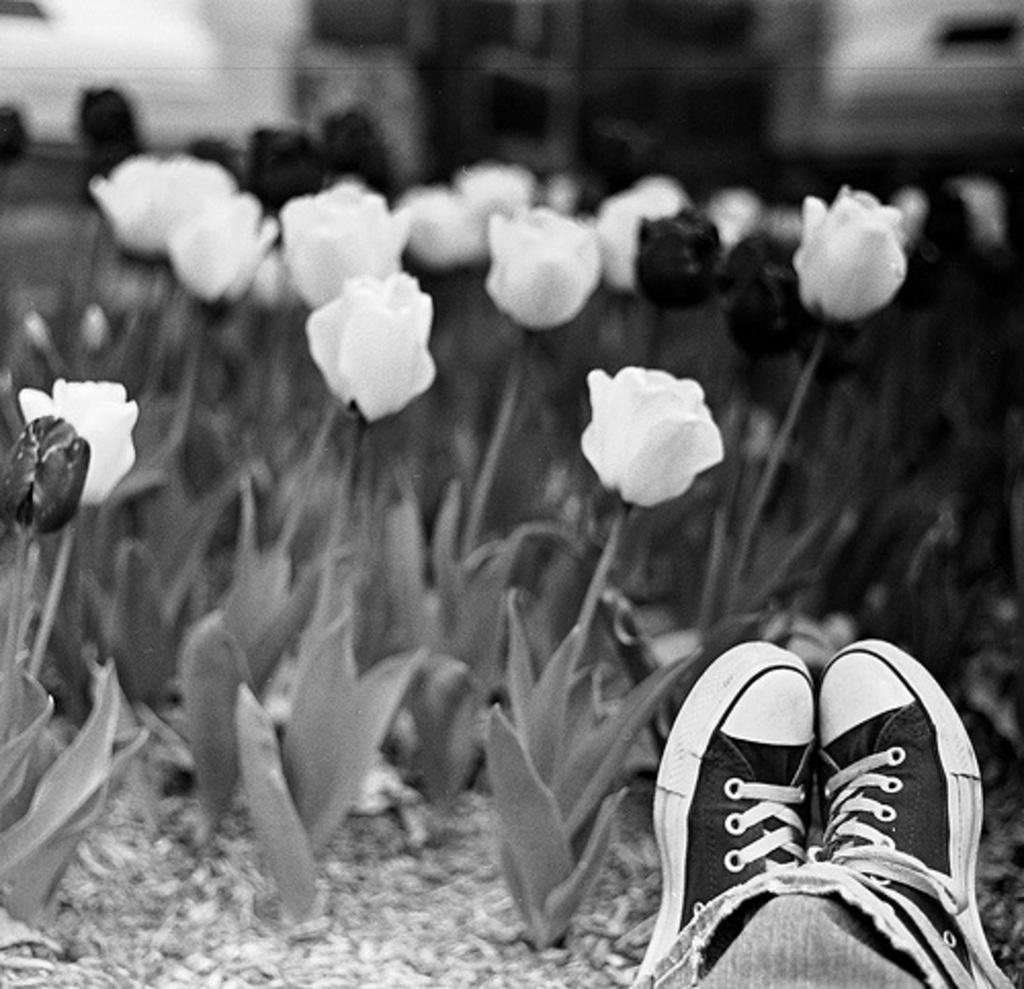Please provide a concise description of this image. In this image, we can see some flowers. There are shoes in the bottom right of the image. 